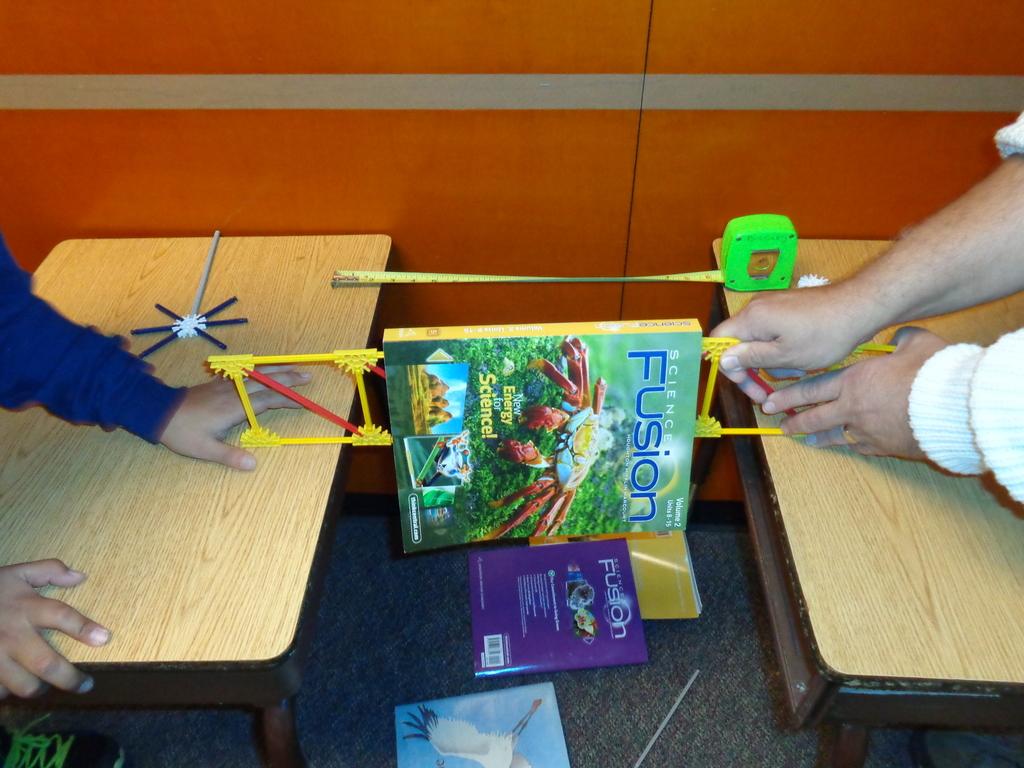What volume number is the book they are playing with?
Give a very brief answer. 2. What is the name of the green book?
Provide a short and direct response. Fusion. 